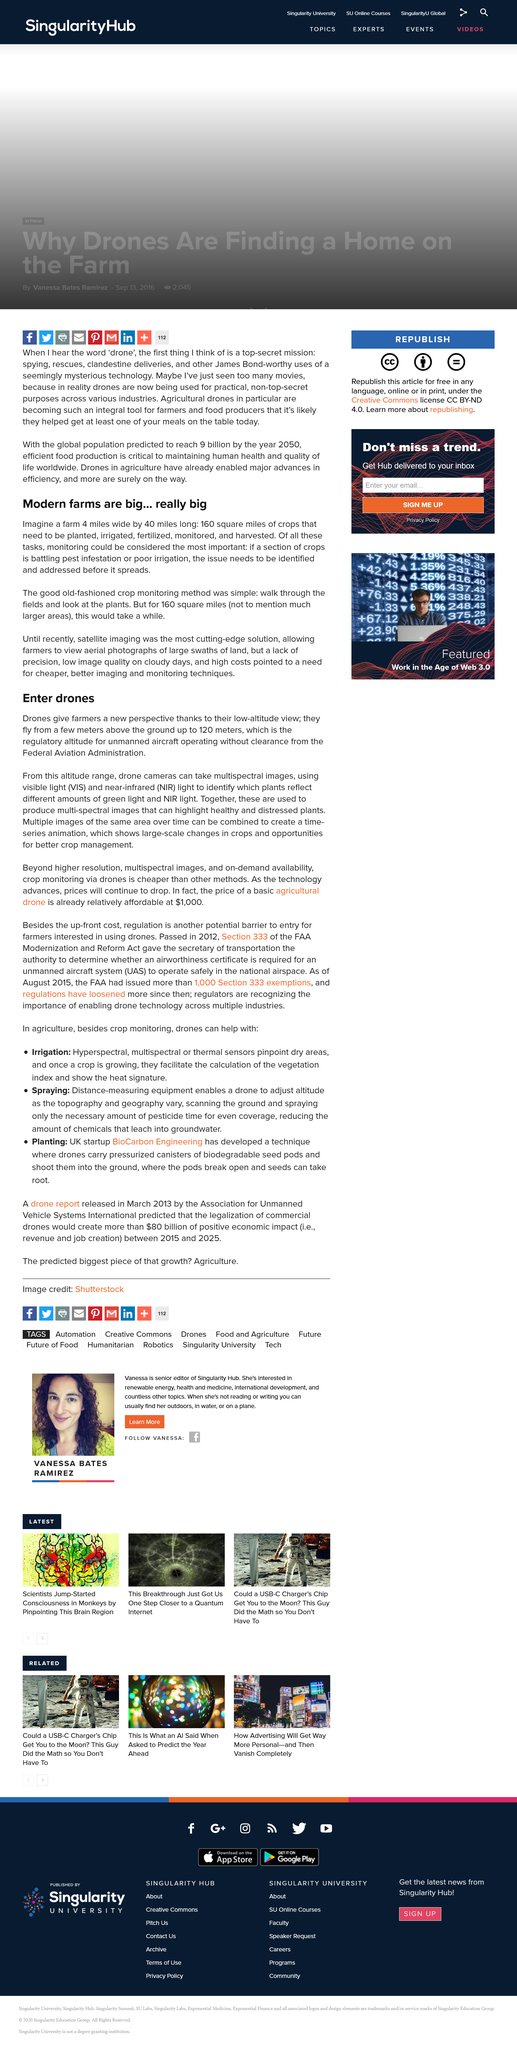Point out several critical features in this image. In the past, farmers monitored their smaller farms by physically walking through their fields and inspecting the plants to ensure their health and growth. The Federal Aviation Administration has set a limit of 120 meters as the maximum altitude that can be reached without clearance. This research aims to identify which plants reflect different amounts of green light and near-infrared light using visible light and near-infrared light from drones. The most advanced method for monitoring large farms was found to be satellite imaging, which was considered to be the most cutting-edge solution in this regard. A modern farm may cover approximately 160 square miles of crops, with the potential to produce a significant amount of food. 